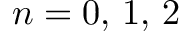Convert formula to latex. <formula><loc_0><loc_0><loc_500><loc_500>n = 0 , \, 1 , \, 2</formula> 